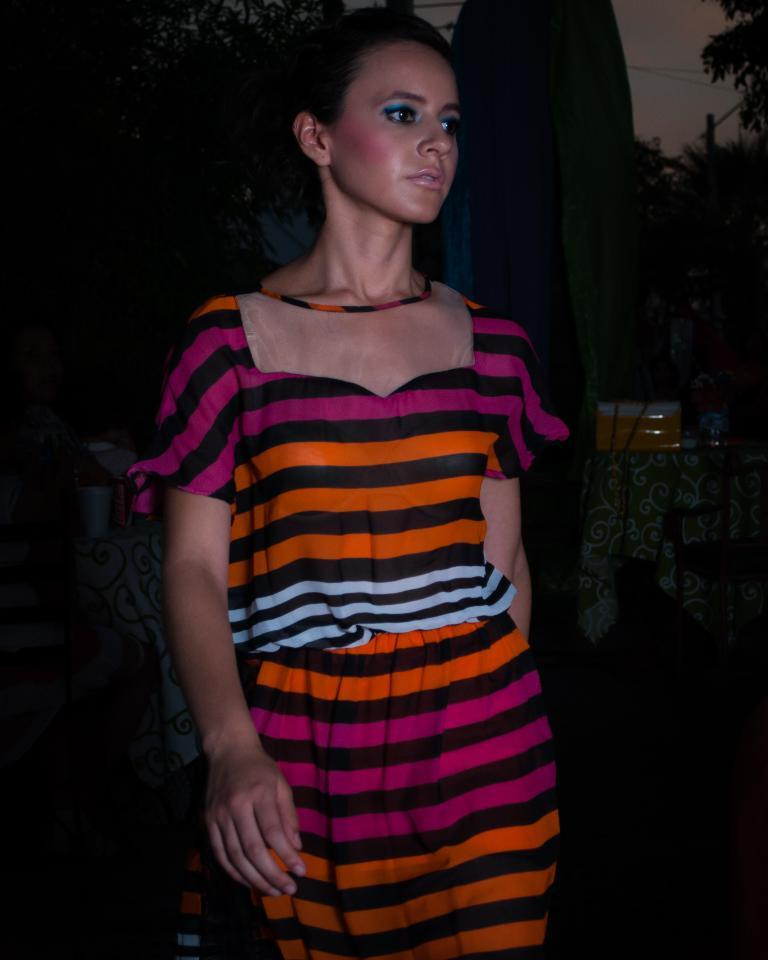Who is in the image? There is a woman in the image. What is the color of the background in the image? The background of the image is dark. What can be seen in the background of the image? Trees, clothes, wires, and the sky are visible in the background of the image. What type of quill is the woman using to write in the image? There is no quill present in the image, and the woman is not shown writing. 